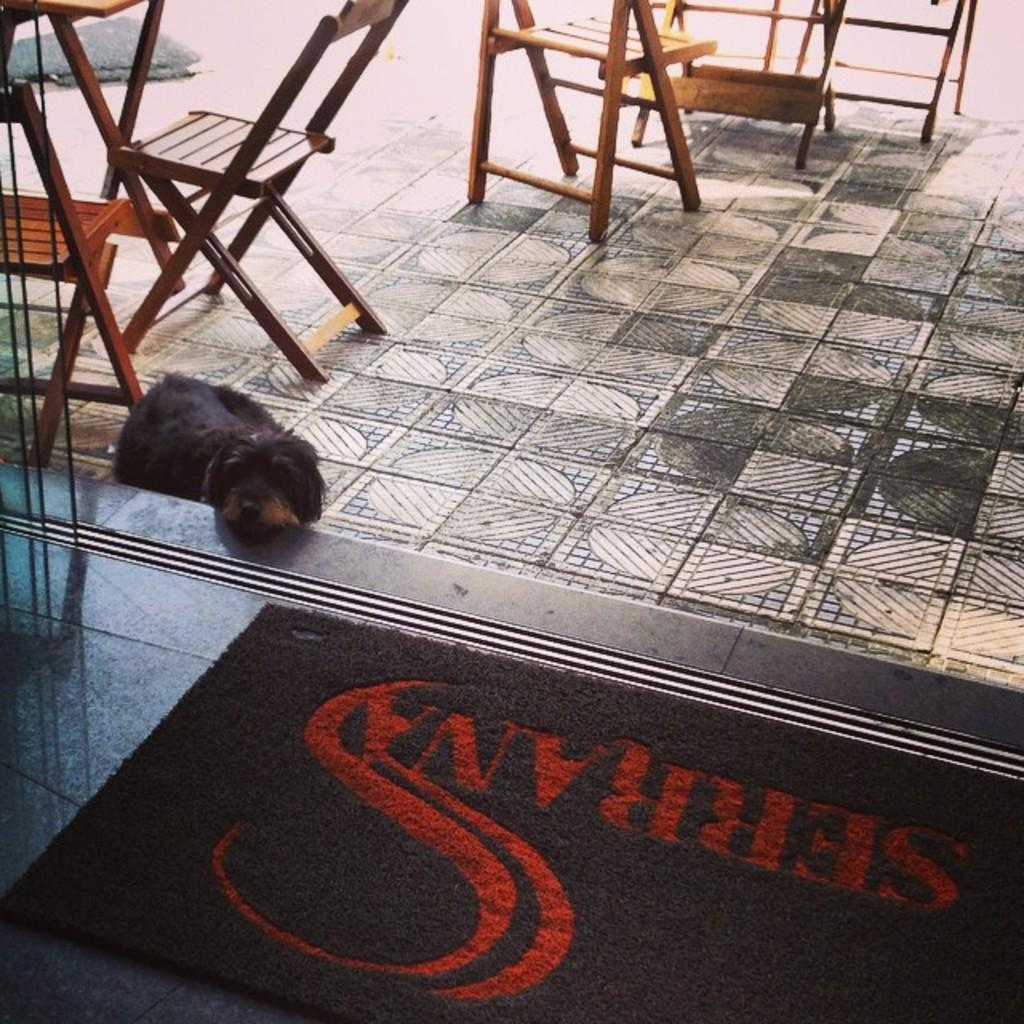What material are the chairs made of in the image? The chairs are made of wood. What color is the mat in the image? There is a black-colored mat in the image. What type of animal can be seen in the image? There is a black-colored dog in the image. How many legs does the sand have in the image? There is no sand present in the image, so it is not possible to determine the number of legs it might have. 